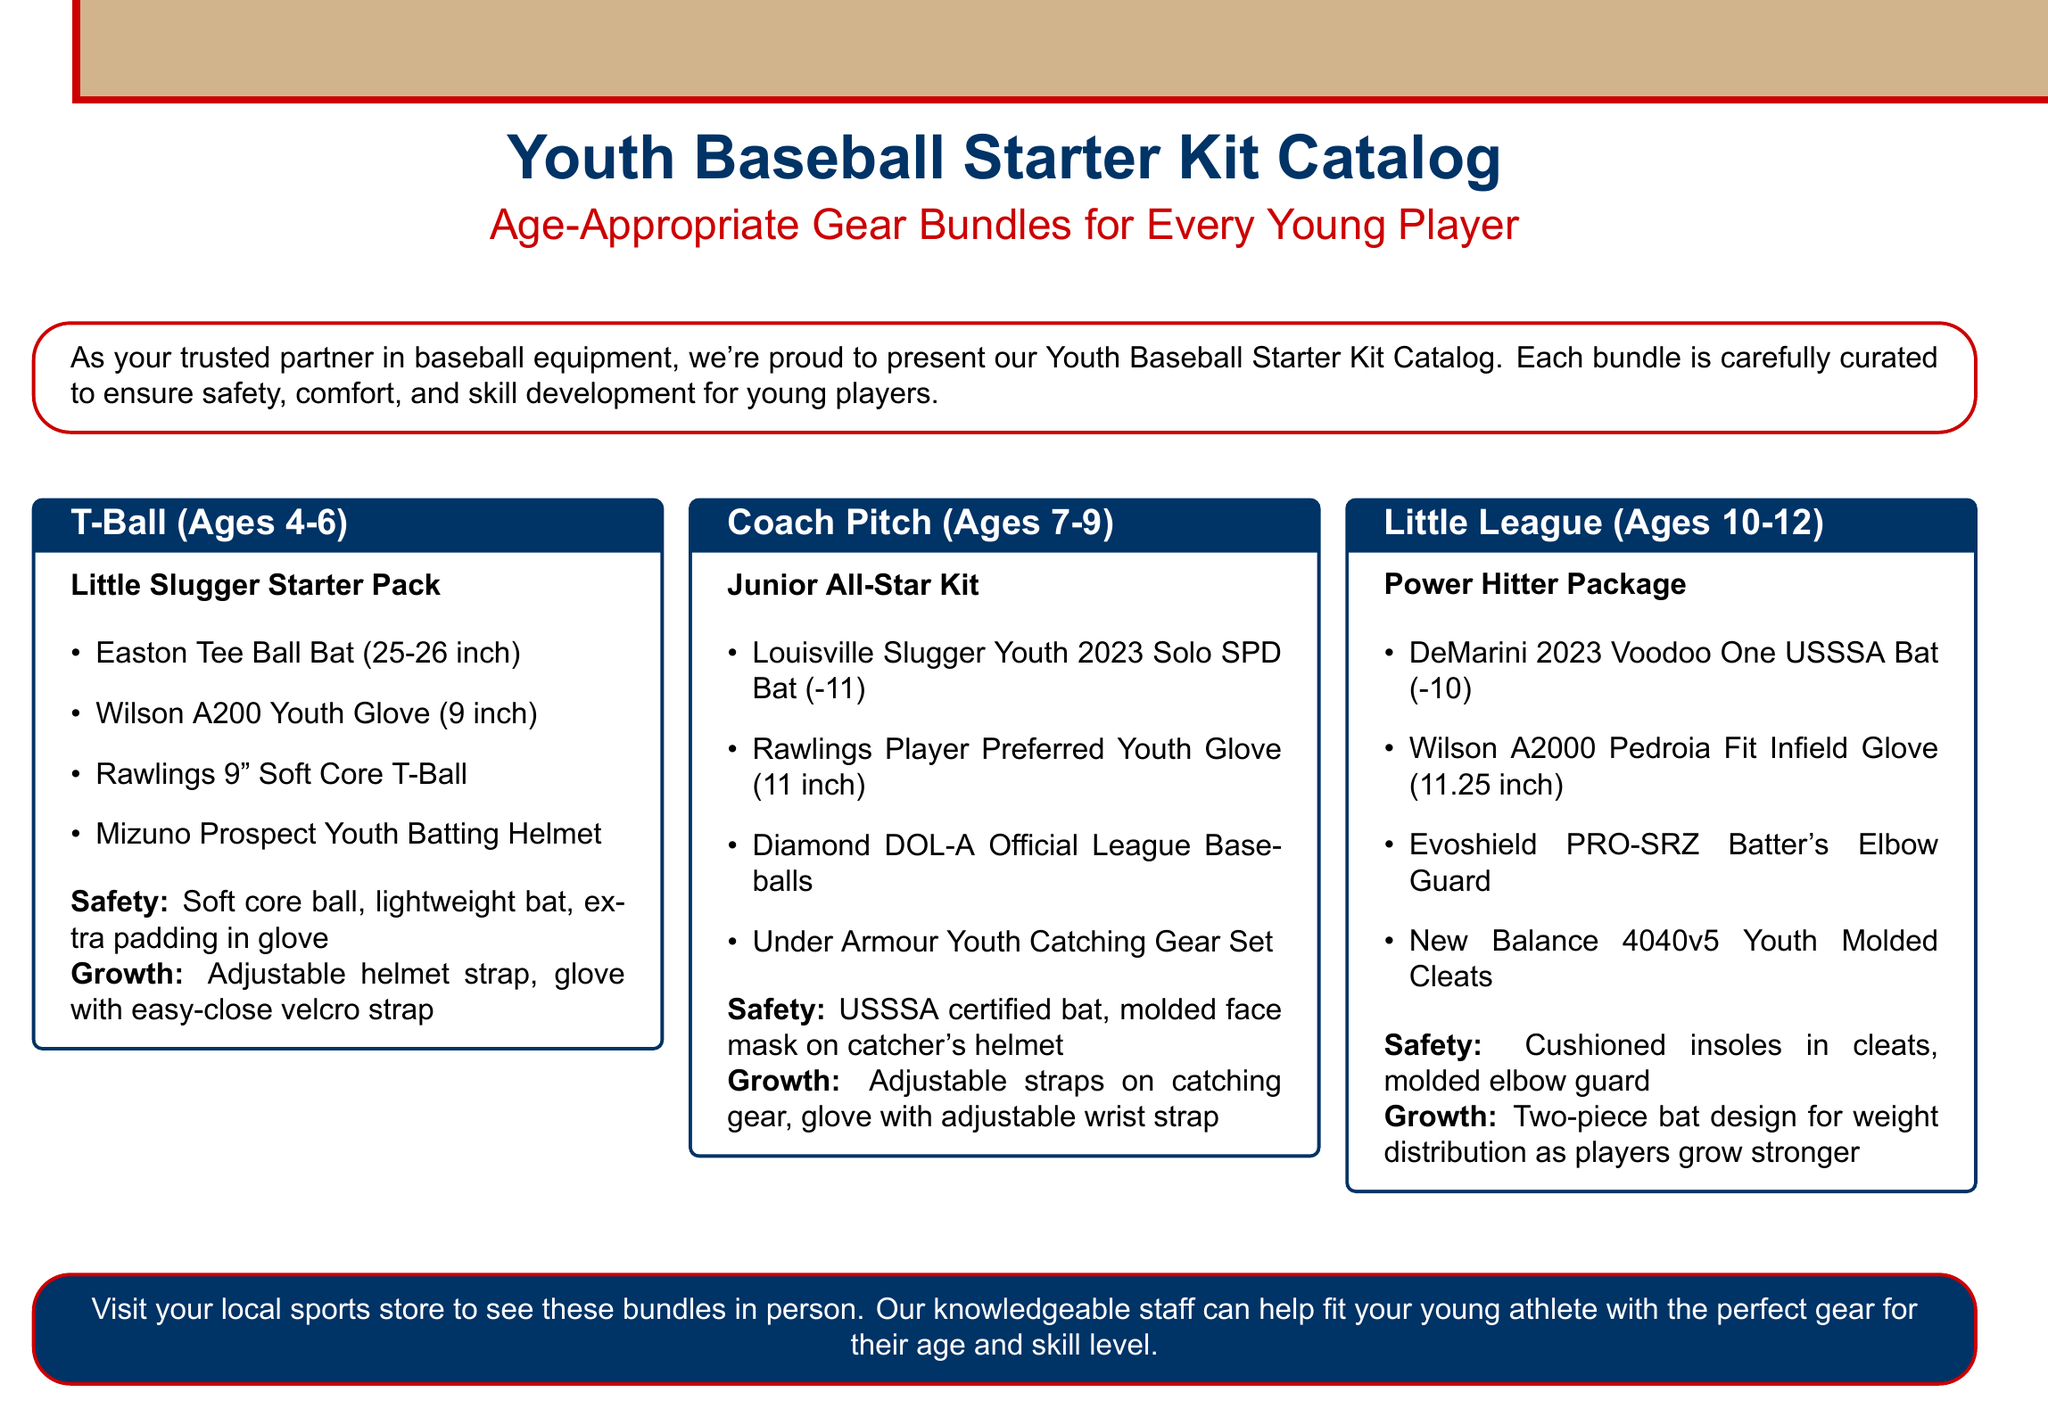What is the age range for T-Ball gear? The age range for T-Ball gear is specified as ages 4-6 in the document.
Answer: Ages 4-6 What item is included in the Junior All-Star Kit? The Junior All-Star Kit includes several items such as a bat, glove, baseballs, and catching gear. One specific item is the Louisville Slugger Youth 2023 Solo SPD Bat.
Answer: Louisville Slugger Youth 2023 Solo SPD Bat How many inches is the Wilson A200 Youth Glove in the T-Ball kit? The Wilson A200 Youth Glove in the T-Ball kit is 9 inches according to the document.
Answer: 9 inch What is the safety feature of the Little Slugger Starter Pack? The document mentions that the Little Slugger Starter Pack includes features like a soft core ball, lightweight bat, and extra padding in the glove for safety.
Answer: Soft core ball, lightweight bat, extra padding in glove What is the purpose of the adjustable strap in the catching gear? The adjustable straps on the catching gear are aimed at ensuring proper fit as players grow, which is also highlighted in the document.
Answer: Ensuring proper fit What is the title of the package for ages 10-12? The document indicates that the title of the package for ages 10-12 is the Power Hitter Package.
Answer: Power Hitter Package How does the Power Hitter Package support growth? A specific growth consideration mentioned in the document is that the Power Hitter Package features a two-piece bat design for weight distribution as players grow stronger.
Answer: Two-piece bat design Which baseball is included in the Junior All-Star Kit? The Junior All-Star Kit includes Diamond DOL-A Official League Baseballs as listed in the document.
Answer: Diamond DOL-A Official League Baseballs What color is the background of the catalog? The document states that the background color of the catalog is baseball tan.
Answer: Baseball tan 